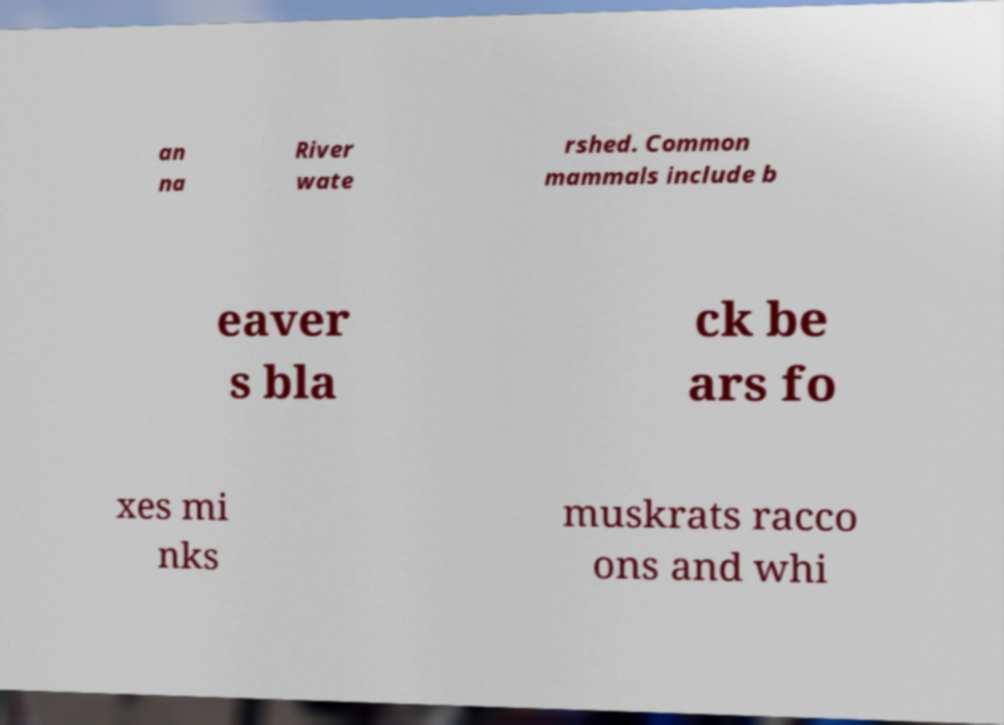Please read and relay the text visible in this image. What does it say? an na River wate rshed. Common mammals include b eaver s bla ck be ars fo xes mi nks muskrats racco ons and whi 